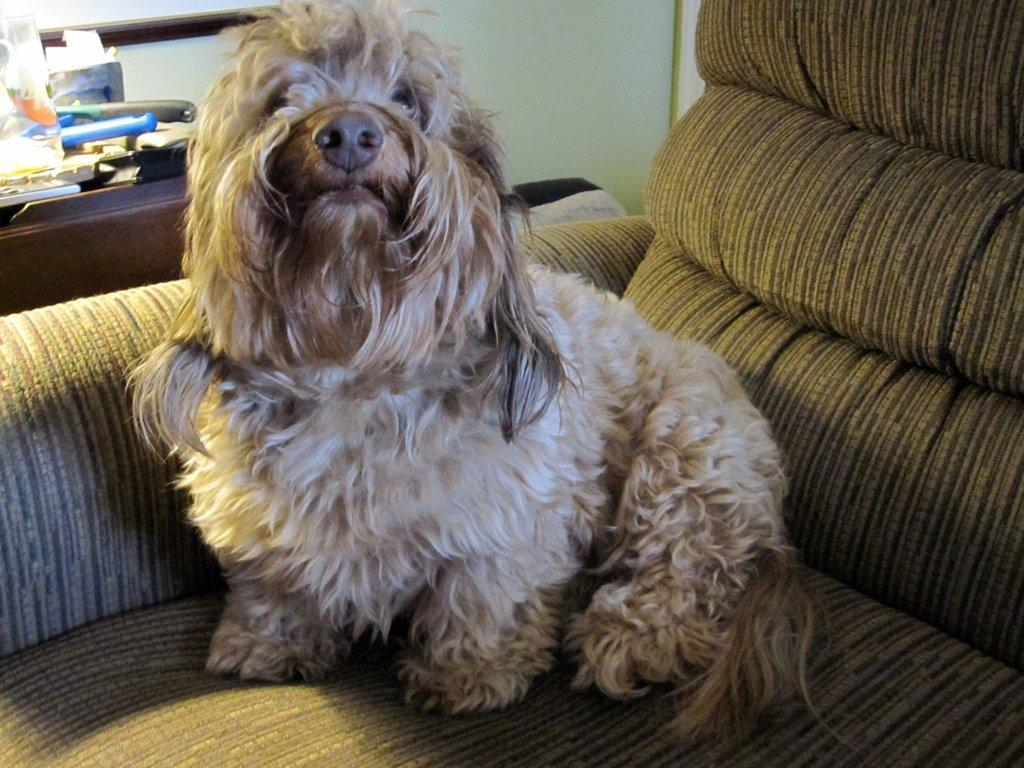What type of animal is in the image? There is a dog in the image. What colors can be seen on the dog? The dog has brown, cream, and black colors. Where is the dog located in the image? The dog is on a couch. What color is the couch? The couch is green in color. What can be seen in the background of the image? There is a wall visible in the background of the image, and there are other objects present as well. What type of acoustics can be heard from the dog in the image? There is no sound or acoustics present in the image, as it is a still photograph. Can you tell me how many hearts the dog has in the image? The image does not show the dog's internal organs, so it is impossible to determine the number of hearts it has. 